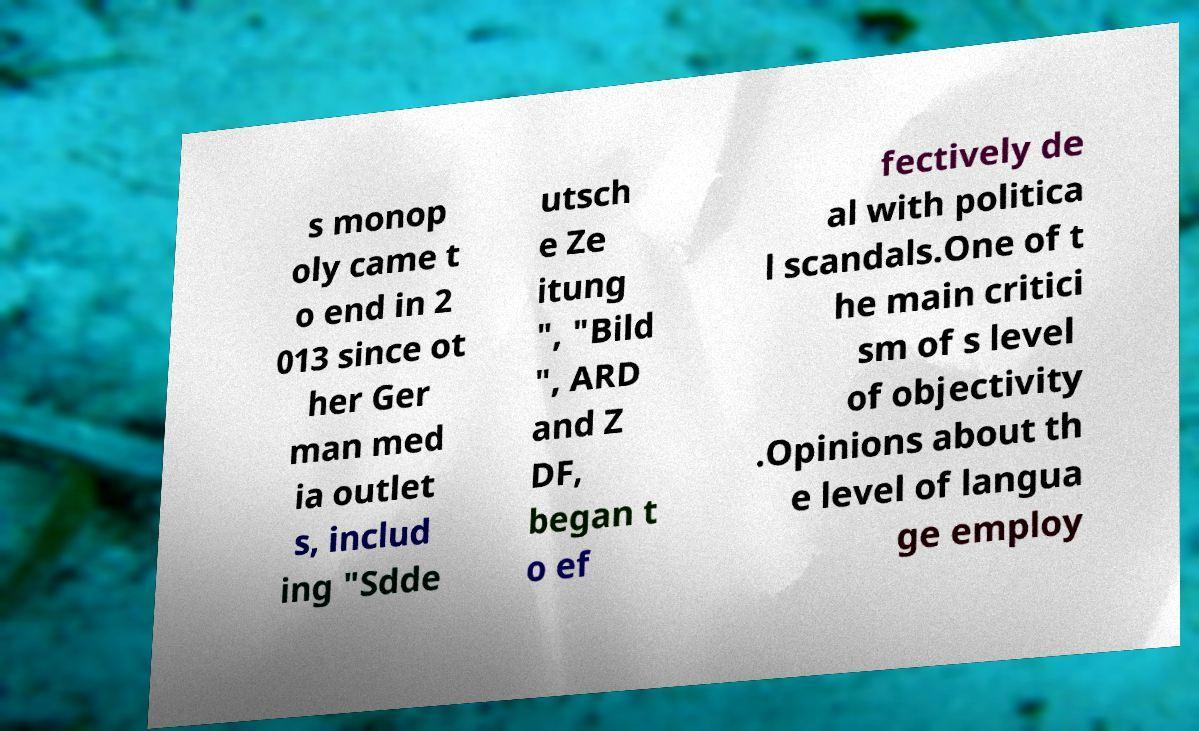There's text embedded in this image that I need extracted. Can you transcribe it verbatim? s monop oly came t o end in 2 013 since ot her Ger man med ia outlet s, includ ing "Sdde utsch e Ze itung ", "Bild ", ARD and Z DF, began t o ef fectively de al with politica l scandals.One of t he main critici sm of s level of objectivity .Opinions about th e level of langua ge employ 